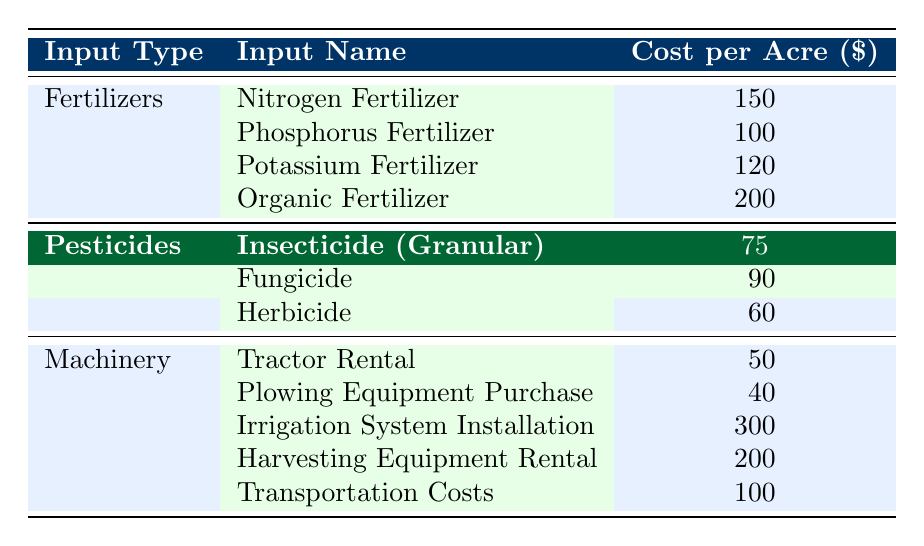What is the cost per acre for Nitrogen Fertilizer? The table lists the cost per acre for various inputs. The row corresponding to Nitrogen Fertilizer shows a cost of 150.
Answer: 150 What is the total cost per acre for all the types of fertilizers combined? To find the total cost for fertilizers, I add the costs of all fertilizer types: Nitrogen (150) + Phosphorus (100) + Potassium (120) + Organic (200) = 570.
Answer: 570 Is the cost of Irrigation System Installation higher than the combined cost of all pesticides? The cost for Irrigation System Installation is 300, while the combined cost of pesticides is: Insecticide (75) + Fungicide (90) + Herbicide (60) = 225. Since 300 is greater than 225, the answer is yes.
Answer: Yes What is the least expensive pesticide per acre? Looking at the pesticide section, the costs are Insecticide (75), Fungicide (90), and Herbicide (60). The least expensive is Herbicide at 60.
Answer: 60 What is the average cost of machinery inputs per acre? The machinery costs are: Tractor Rental (50), Plowing Equipment Purchase (40), Irrigation System Installation (300), Harvesting Equipment Rental (200), and Transportation Costs (100). The total cost for machinery is 50 + 40 + 300 + 200 + 100 = 690. There are 5 machinery inputs, so the average is 690 / 5 = 138.
Answer: 138 Do the total costs of fertilizers exceed the total costs of machinery? The total cost of fertilizers is 570, while the total cost of machinery is: 50 + 40 + 300 + 200 + 100 = 690. Since 570 is less than 690, the answer is no.
Answer: No What is the cost difference between Organic Fertilizer and the most expensive machinery input? The cost of Organic Fertilizer is 200 and the most expensive machinery input, Irrigation System Installation, costs 300. The difference is 300 - 200 = 100.
Answer: 100 Which category has the highest single input cost, and what is that cost? Looking at the costs, Irrigation System Installation (300) is the highest single input cost among all inputs. Fertilizers and pesticides do not exceed this amount.
Answer: 300 What is the total cost per acre for all inputs in the table? To find the total cost for all inputs, I add the total costs of fertilizers (570), pesticides (225), and machinery (690): 570 + 225 + 690 = 1485.
Answer: 1485 